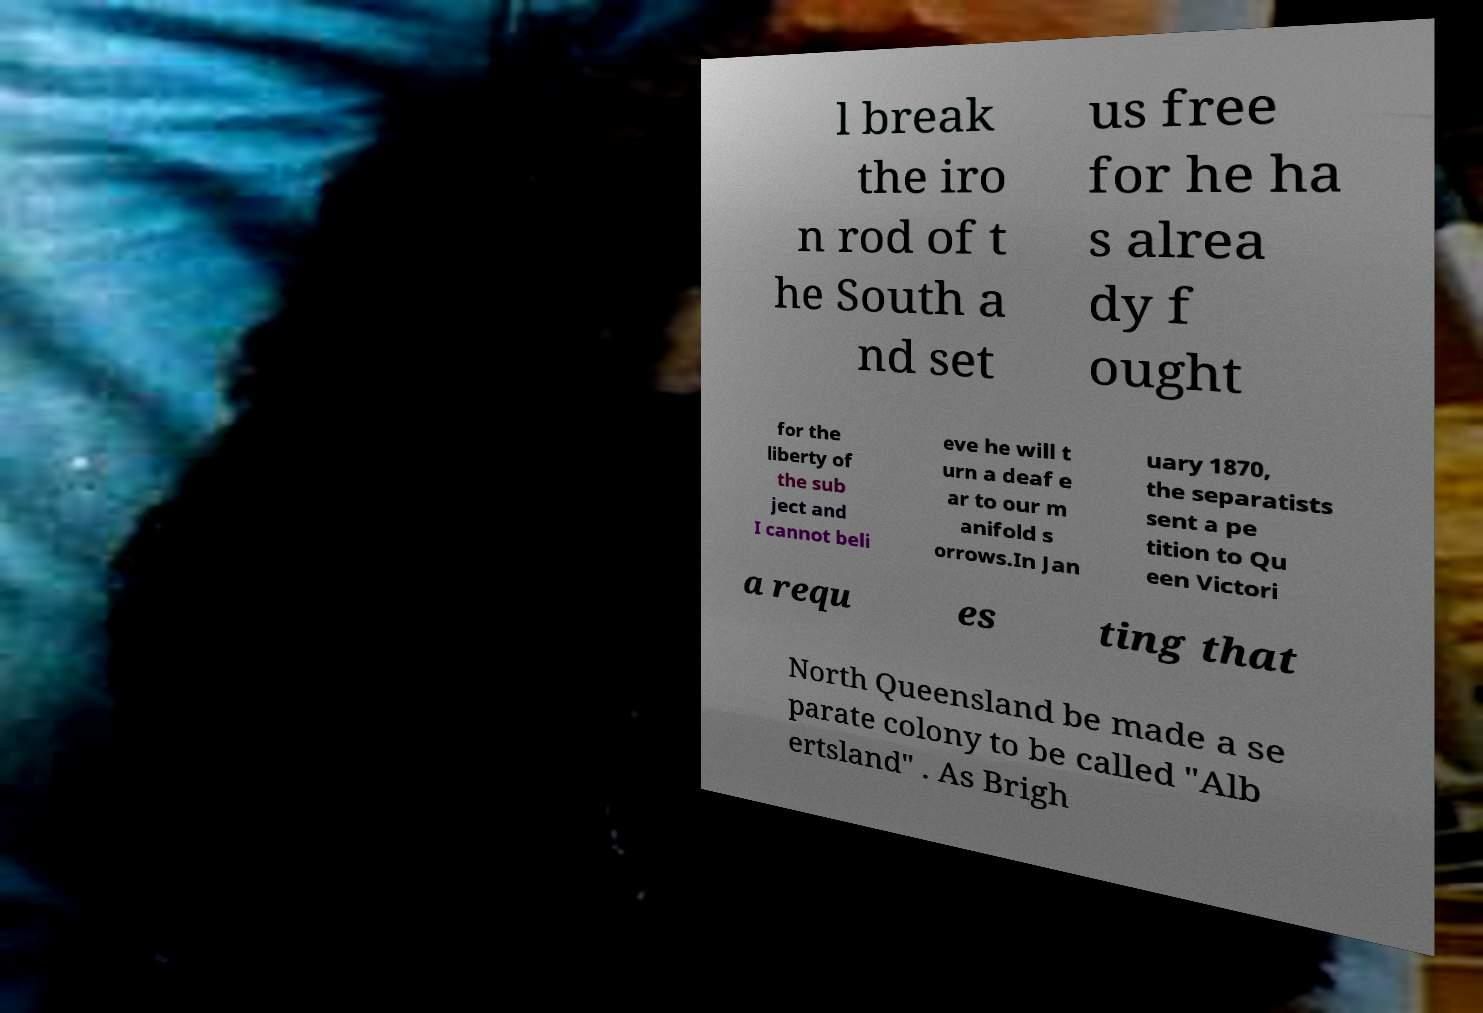Please identify and transcribe the text found in this image. l break the iro n rod of t he South a nd set us free for he ha s alrea dy f ought for the liberty of the sub ject and I cannot beli eve he will t urn a deaf e ar to our m anifold s orrows.In Jan uary 1870, the separatists sent a pe tition to Qu een Victori a requ es ting that North Queensland be made a se parate colony to be called "Alb ertsland" . As Brigh 